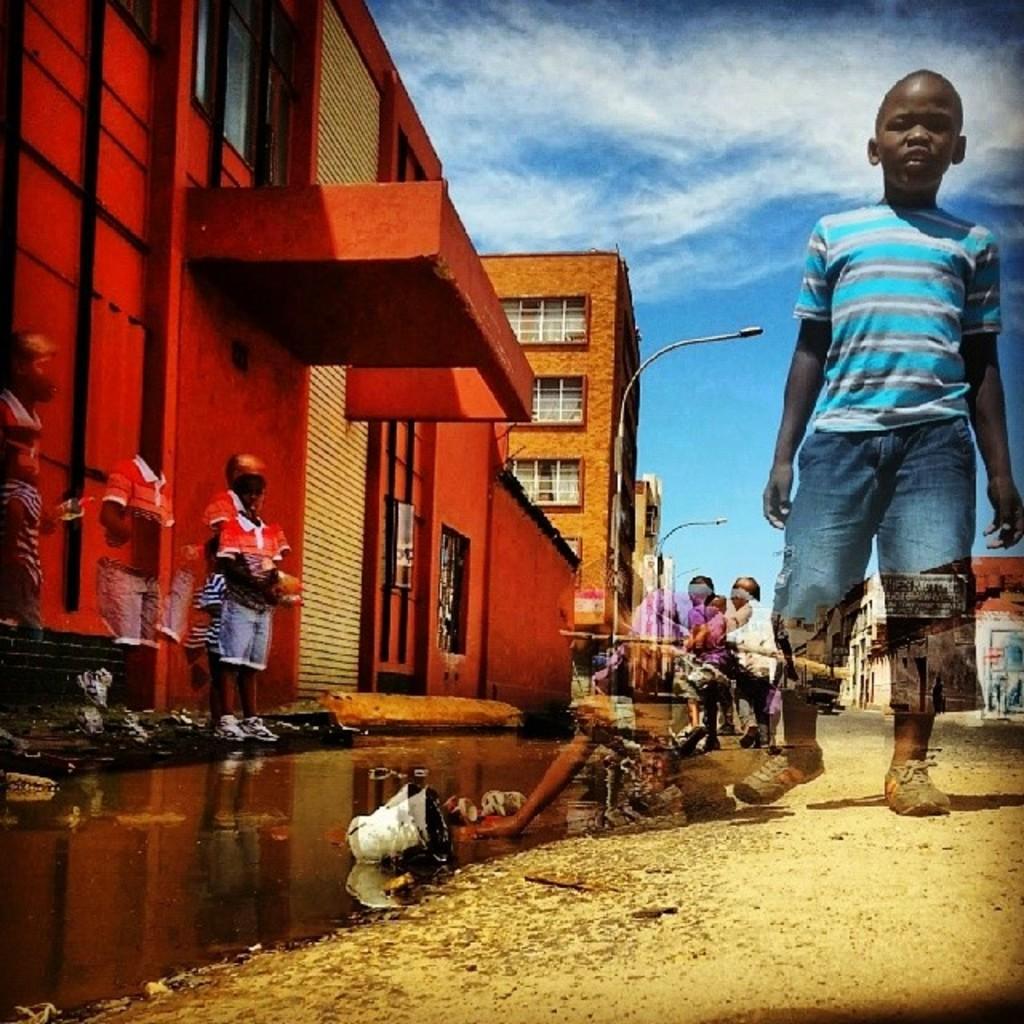Describe this image in one or two sentences. In this image we can see a few children, there are some buildings, windows, poles, lights and water, in the water we can see some objects and in the background we can see the sky with clouds. 